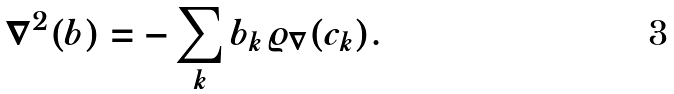Convert formula to latex. <formula><loc_0><loc_0><loc_500><loc_500>\nabla ^ { 2 } ( b ) = - \sum _ { k } b _ { k } \varrho _ { \nabla } ( c _ { k } ) .</formula> 